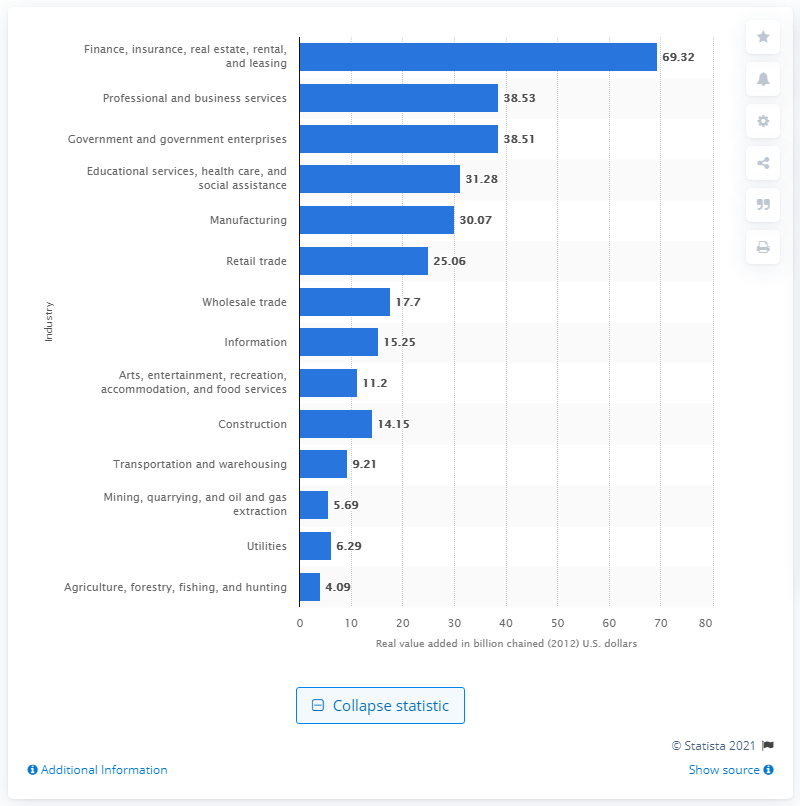Specify some key components in this picture. The finance, insurance, real estate, rental, and leasing industry contributed 69.32% to Arizona's gross domestic product in 2020. 